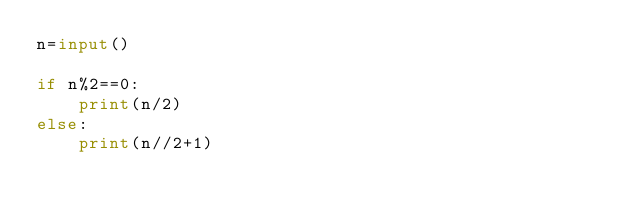<code> <loc_0><loc_0><loc_500><loc_500><_Python_>n=input()

if n%2==0:
    print(n/2)
else:
    print(n//2+1)</code> 